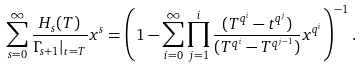<formula> <loc_0><loc_0><loc_500><loc_500>\sum _ { s = 0 } ^ { \infty } \frac { H _ { s } ( T ) } { \Gamma _ { s + 1 } | _ { t = T } } x ^ { s } = \left ( 1 - \sum _ { i = 0 } ^ { \infty } \prod _ { j = 1 } ^ { i } \frac { ( T ^ { q ^ { i } } - t ^ { q ^ { j } } ) } { ( T ^ { q ^ { i } } - T ^ { q ^ { j - 1 } } ) } x ^ { q ^ { i } } \right ) ^ { - 1 } .</formula> 